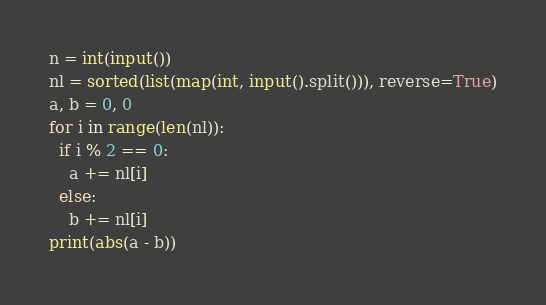Convert code to text. <code><loc_0><loc_0><loc_500><loc_500><_Python_>n = int(input())
nl = sorted(list(map(int, input().split())), reverse=True)
a, b = 0, 0
for i in range(len(nl)):
  if i % 2 == 0:
    a += nl[i]
  else:
    b += nl[i]
print(abs(a - b))</code> 